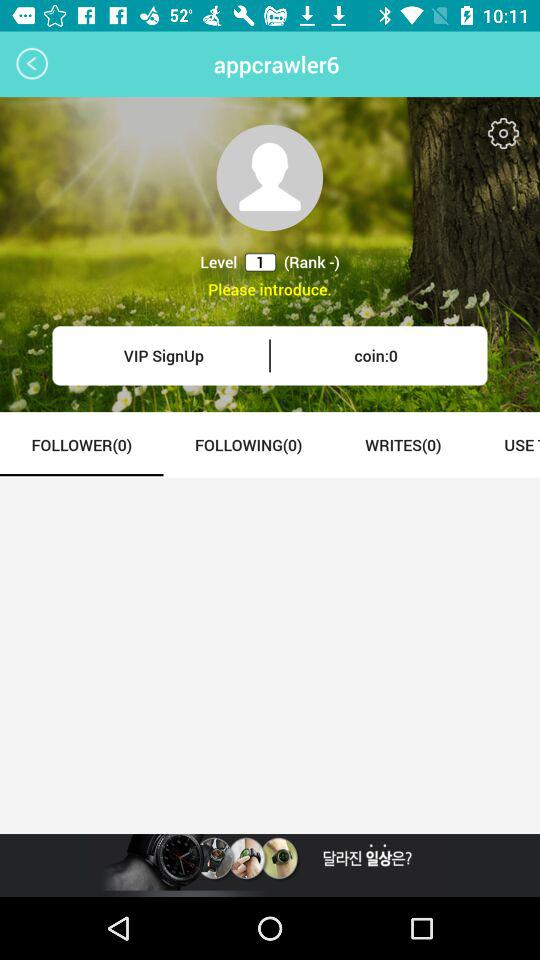How many followers does the user have?
Answer the question using a single word or phrase. 0 